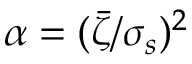Convert formula to latex. <formula><loc_0><loc_0><loc_500><loc_500>\alpha = ( \bar { \zeta } / \sigma _ { s } ) ^ { 2 }</formula> 